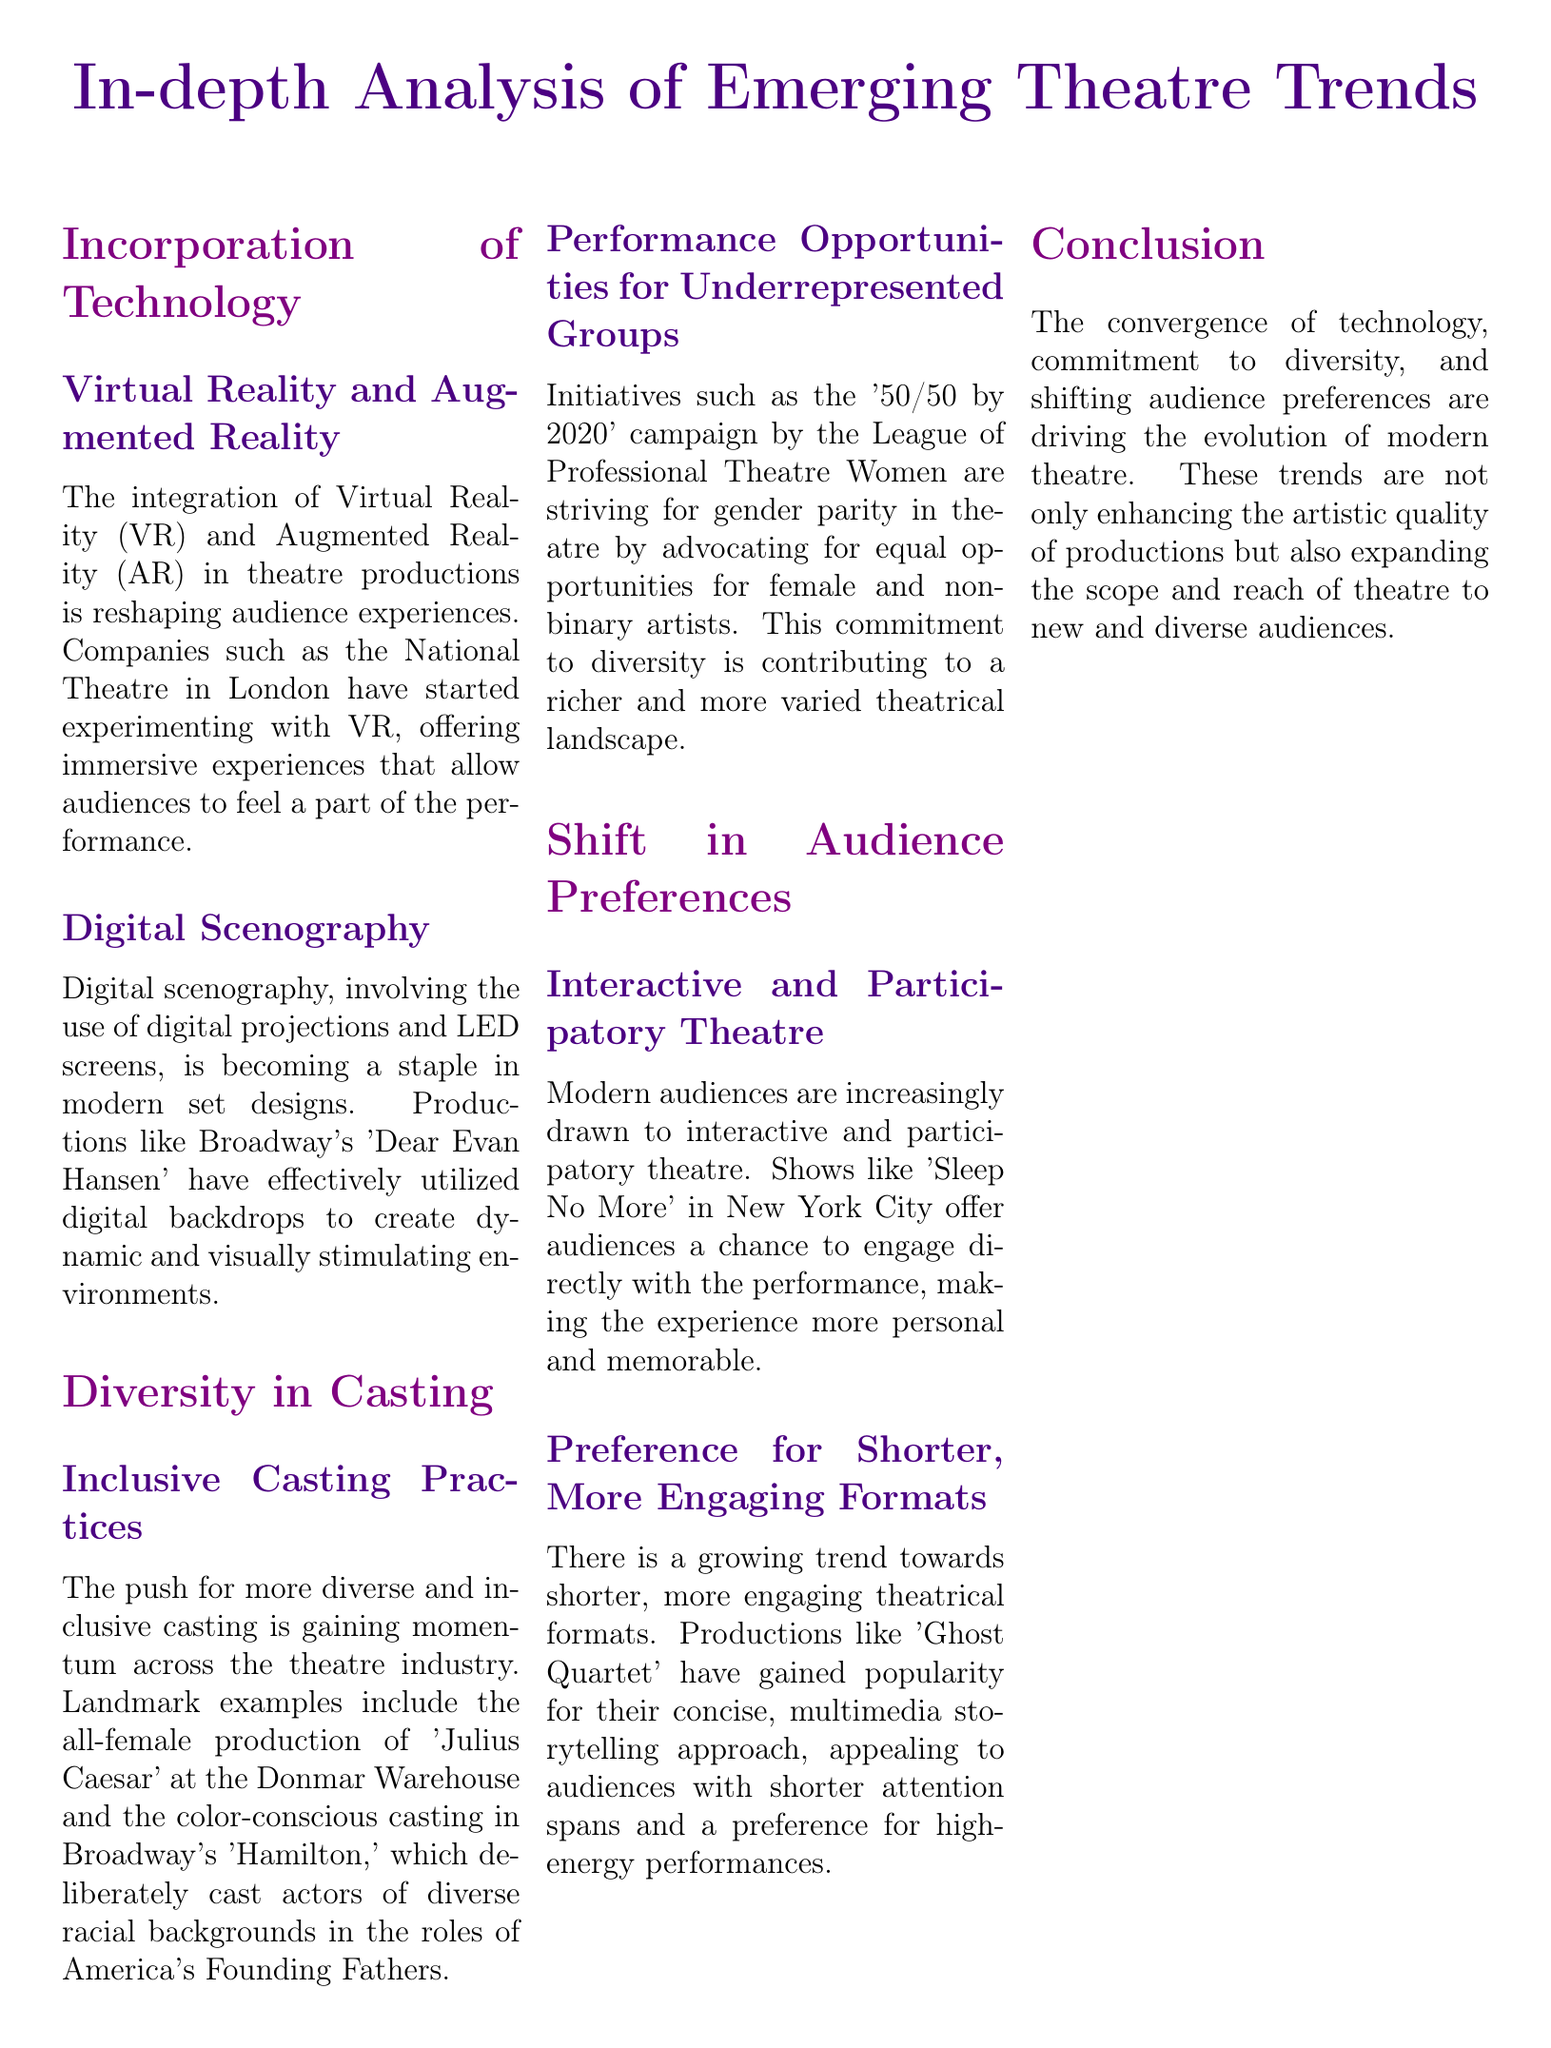What technological integration is reshaping audience experiences? The document mentions the integration of Virtual Reality (VR) and Augmented Reality (AR) in theatre productions for immersive experiences.
Answer: Virtual Reality and Augmented Reality Which production utilized digital backdrops for its set design? 'Dear Evan Hansen' is cited as a production that effectively used digital backdrops in its set design.
Answer: Dear Evan Hansen What campaign aims for gender parity in theatre? The '50/50 by 2020' campaign is mentioned as a movement advocating for equal opportunities for female and non-binary artists.
Answer: 50/50 by 2020 What type of theatre are modern audiences increasingly drawn to? The document states that audiences are drawn to interactive and participatory theatre.
Answer: Interactive and participatory theatre Which show in New York City offers a chance for audience engagement? 'Sleep No More' is highlighted as a show that allows audiences to engage directly with the performance.
Answer: Sleep No More What characterizes the preferred theatrical formats among modern audiences? The document notes a growing trend towards shorter, more engaging theatrical formats.
Answer: Shorter, more engaging formats What is a key characteristic of the performance opportunities being advocated for underrepresented groups? The document addresses the commitment to diversity, contributing to a richer theatrical landscape.
Answer: Commitment to diversity Which notable example features color-conscious casting? 'Hamilton' is pointed out as an example of a production with color-conscious casting.
Answer: Hamilton 